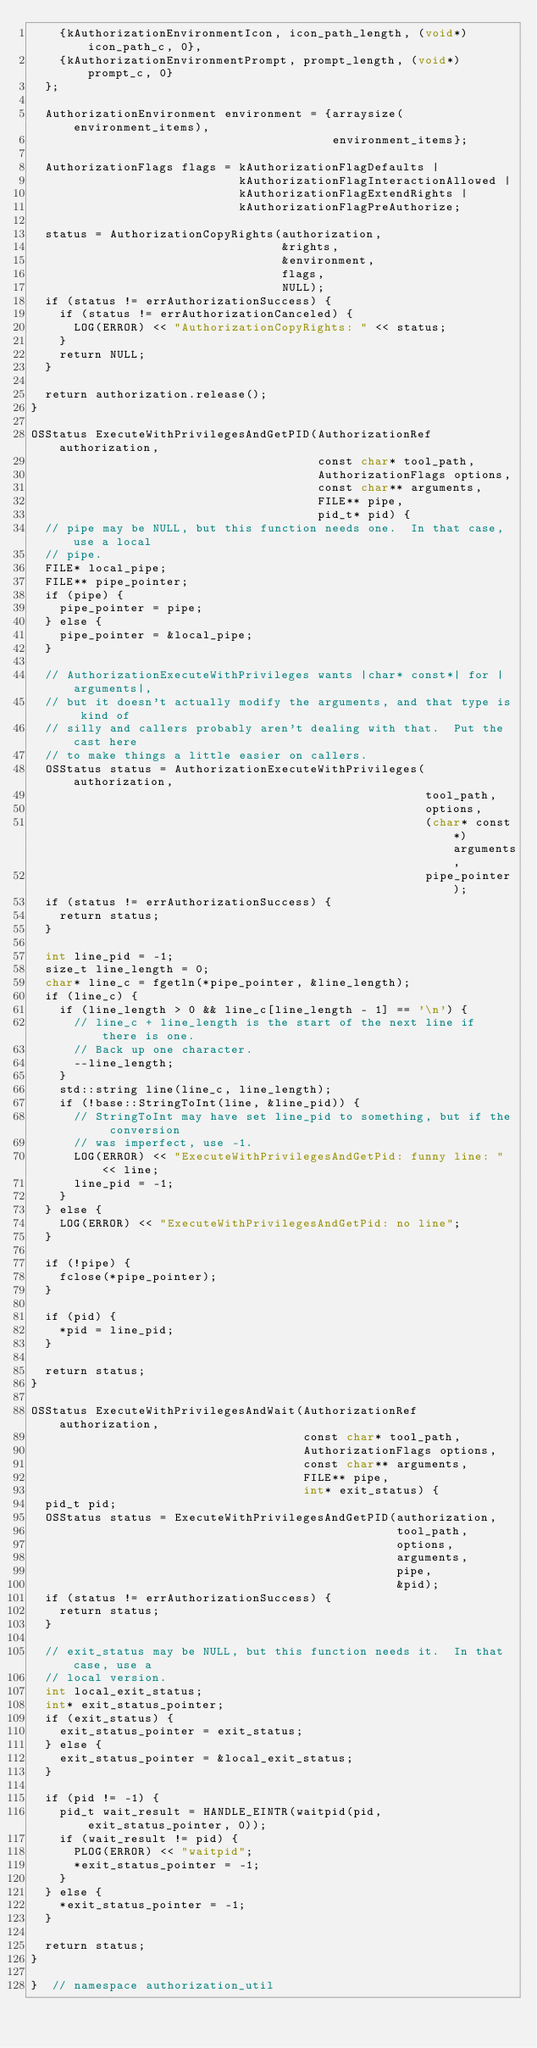<code> <loc_0><loc_0><loc_500><loc_500><_ObjectiveC_>    {kAuthorizationEnvironmentIcon, icon_path_length, (void*)icon_path_c, 0},
    {kAuthorizationEnvironmentPrompt, prompt_length, (void*)prompt_c, 0}
  };

  AuthorizationEnvironment environment = {arraysize(environment_items),
                                          environment_items};

  AuthorizationFlags flags = kAuthorizationFlagDefaults |
                             kAuthorizationFlagInteractionAllowed |
                             kAuthorizationFlagExtendRights |
                             kAuthorizationFlagPreAuthorize;

  status = AuthorizationCopyRights(authorization,
                                   &rights,
                                   &environment,
                                   flags,
                                   NULL);
  if (status != errAuthorizationSuccess) {
    if (status != errAuthorizationCanceled) {
      LOG(ERROR) << "AuthorizationCopyRights: " << status;
    }
    return NULL;
  }

  return authorization.release();
}

OSStatus ExecuteWithPrivilegesAndGetPID(AuthorizationRef authorization,
                                        const char* tool_path,
                                        AuthorizationFlags options,
                                        const char** arguments,
                                        FILE** pipe,
                                        pid_t* pid) {
  // pipe may be NULL, but this function needs one.  In that case, use a local
  // pipe.
  FILE* local_pipe;
  FILE** pipe_pointer;
  if (pipe) {
    pipe_pointer = pipe;
  } else {
    pipe_pointer = &local_pipe;
  }

  // AuthorizationExecuteWithPrivileges wants |char* const*| for |arguments|,
  // but it doesn't actually modify the arguments, and that type is kind of
  // silly and callers probably aren't dealing with that.  Put the cast here
  // to make things a little easier on callers.
  OSStatus status = AuthorizationExecuteWithPrivileges(authorization,
                                                       tool_path,
                                                       options,
                                                       (char* const*)arguments,
                                                       pipe_pointer);
  if (status != errAuthorizationSuccess) {
    return status;
  }

  int line_pid = -1;
  size_t line_length = 0;
  char* line_c = fgetln(*pipe_pointer, &line_length);
  if (line_c) {
    if (line_length > 0 && line_c[line_length - 1] == '\n') {
      // line_c + line_length is the start of the next line if there is one.
      // Back up one character.
      --line_length;
    }
    std::string line(line_c, line_length);
    if (!base::StringToInt(line, &line_pid)) {
      // StringToInt may have set line_pid to something, but if the conversion
      // was imperfect, use -1.
      LOG(ERROR) << "ExecuteWithPrivilegesAndGetPid: funny line: " << line;
      line_pid = -1;
    }
  } else {
    LOG(ERROR) << "ExecuteWithPrivilegesAndGetPid: no line";
  }

  if (!pipe) {
    fclose(*pipe_pointer);
  }

  if (pid) {
    *pid = line_pid;
  }

  return status;
}

OSStatus ExecuteWithPrivilegesAndWait(AuthorizationRef authorization,
                                      const char* tool_path,
                                      AuthorizationFlags options,
                                      const char** arguments,
                                      FILE** pipe,
                                      int* exit_status) {
  pid_t pid;
  OSStatus status = ExecuteWithPrivilegesAndGetPID(authorization,
                                                   tool_path,
                                                   options,
                                                   arguments,
                                                   pipe,
                                                   &pid);
  if (status != errAuthorizationSuccess) {
    return status;
  }

  // exit_status may be NULL, but this function needs it.  In that case, use a
  // local version.
  int local_exit_status;
  int* exit_status_pointer;
  if (exit_status) {
    exit_status_pointer = exit_status;
  } else {
    exit_status_pointer = &local_exit_status;
  }

  if (pid != -1) {
    pid_t wait_result = HANDLE_EINTR(waitpid(pid, exit_status_pointer, 0));
    if (wait_result != pid) {
      PLOG(ERROR) << "waitpid";
      *exit_status_pointer = -1;
    }
  } else {
    *exit_status_pointer = -1;
  }

  return status;
}

}  // namespace authorization_util
</code> 